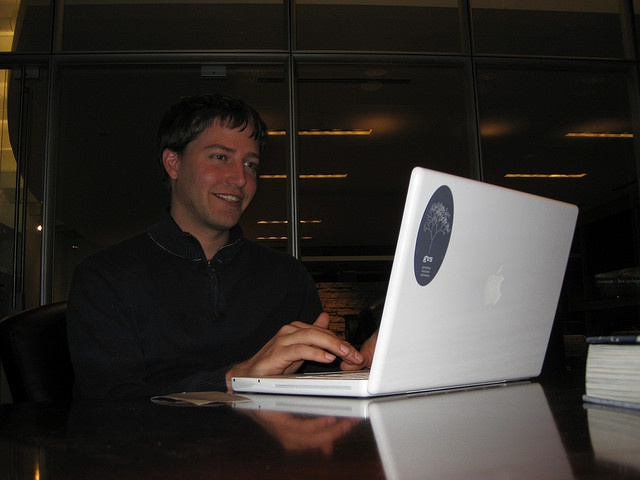Describe the objects in this image and their specific colors. I can see people in maroon, black, and brown tones, laptop in maroon, darkgray, lightgray, gray, and black tones, chair in black and maroon tones, and book in maroon, darkgray, gray, and black tones in this image. 